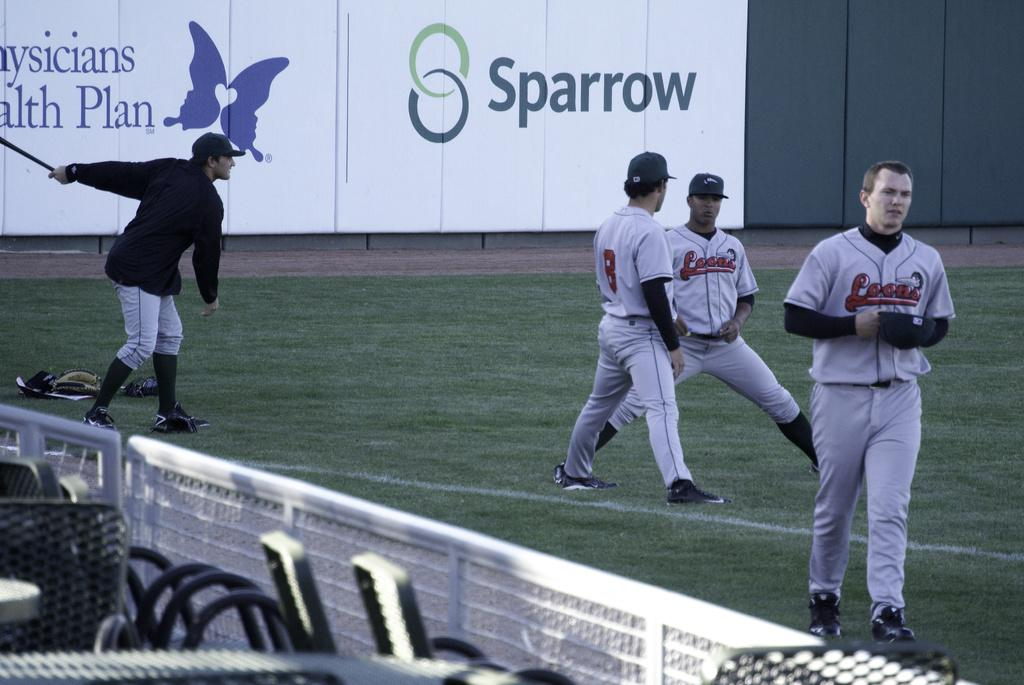<image>
Share a concise interpretation of the image provided. On the outfield wall is a banner sponsored by Sparrow. 